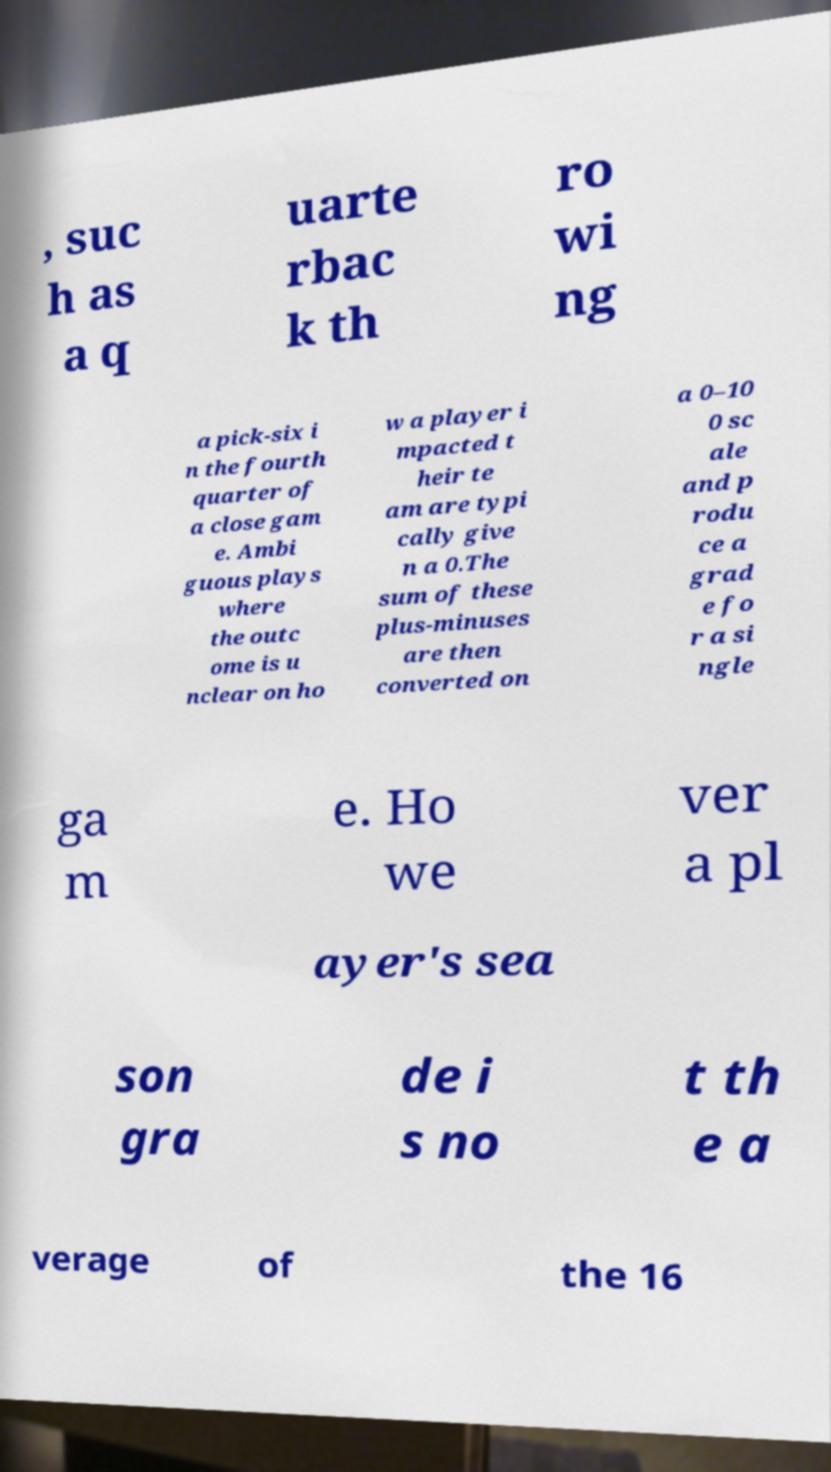Please read and relay the text visible in this image. What does it say? , suc h as a q uarte rbac k th ro wi ng a pick-six i n the fourth quarter of a close gam e. Ambi guous plays where the outc ome is u nclear on ho w a player i mpacted t heir te am are typi cally give n a 0.The sum of these plus-minuses are then converted on a 0–10 0 sc ale and p rodu ce a grad e fo r a si ngle ga m e. Ho we ver a pl ayer's sea son gra de i s no t th e a verage of the 16 